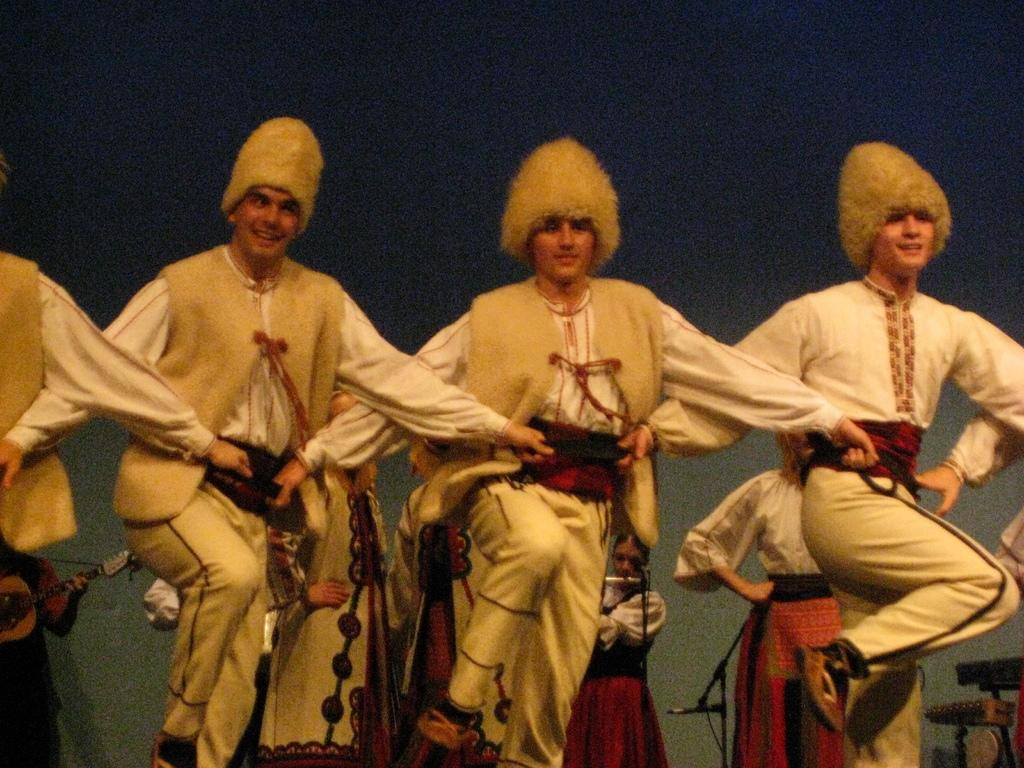What is happening in the image involving a group of men? The men in the image are dancing. What are the men wearing? The men are wearing similar dress. Can you describe the women in the background of the image? The women in the background are playing musical instruments. How would you describe the lighting in the image? The background view is dark. How many beams are supporting the stage in the image? There is no stage or beams present in the image. Can you tell me how much a ticket to this event costs? There is no information about tickets or an event in the image. 